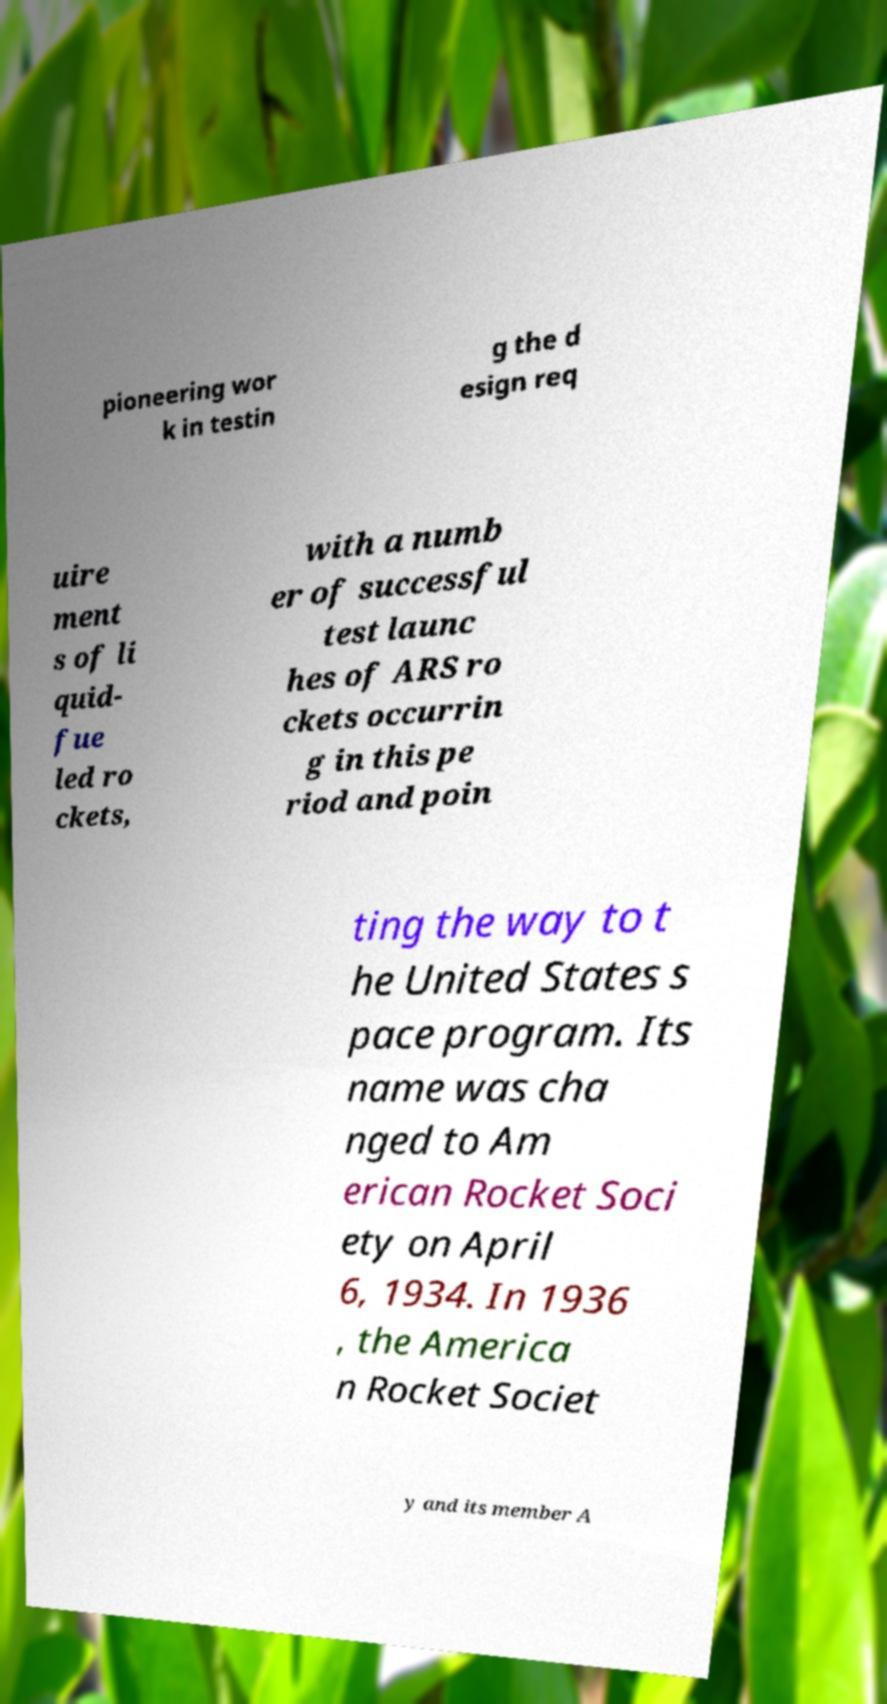What messages or text are displayed in this image? I need them in a readable, typed format. pioneering wor k in testin g the d esign req uire ment s of li quid- fue led ro ckets, with a numb er of successful test launc hes of ARS ro ckets occurrin g in this pe riod and poin ting the way to t he United States s pace program. Its name was cha nged to Am erican Rocket Soci ety on April 6, 1934. In 1936 , the America n Rocket Societ y and its member A 